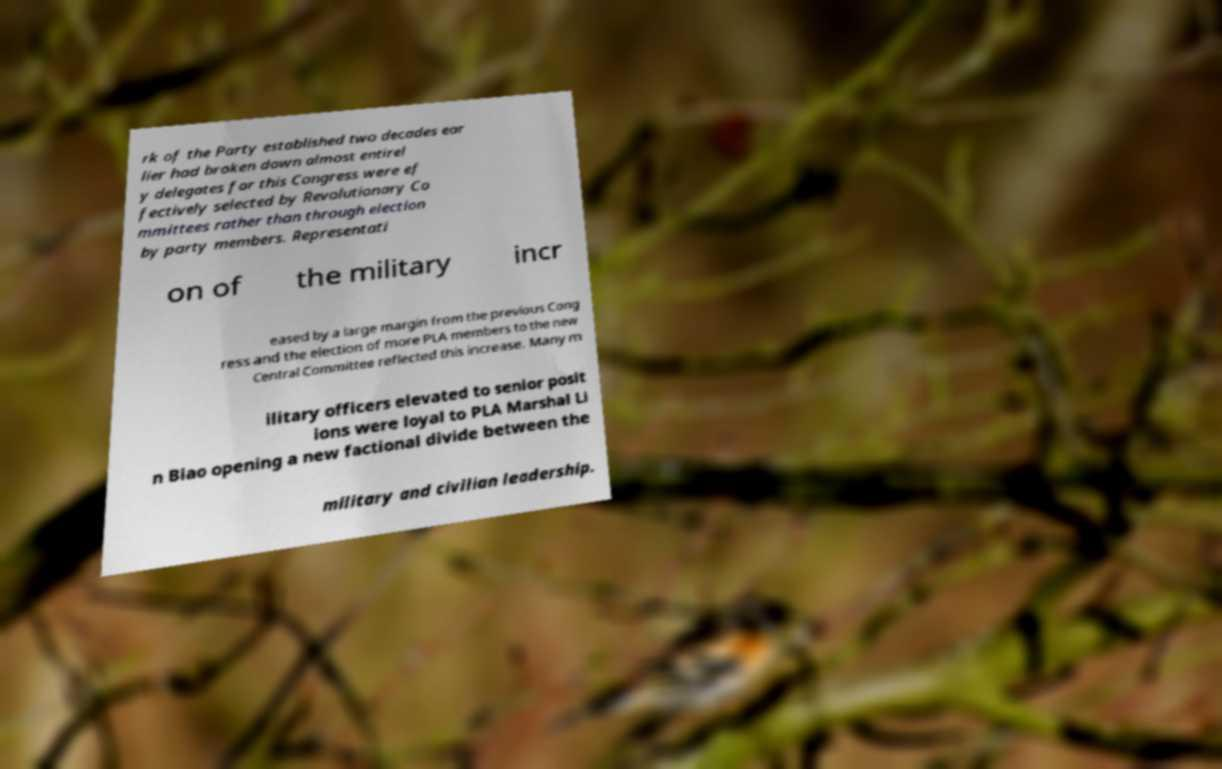Can you accurately transcribe the text from the provided image for me? rk of the Party established two decades ear lier had broken down almost entirel y delegates for this Congress were ef fectively selected by Revolutionary Co mmittees rather than through election by party members. Representati on of the military incr eased by a large margin from the previous Cong ress and the election of more PLA members to the new Central Committee reflected this increase. Many m ilitary officers elevated to senior posit ions were loyal to PLA Marshal Li n Biao opening a new factional divide between the military and civilian leadership. 